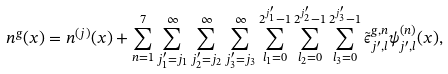<formula> <loc_0><loc_0><loc_500><loc_500>n ^ { g } ( { x } ) = n ^ { ( { j } ) } ( { x } ) + \sum _ { n = 1 } ^ { 7 } \sum _ { j ^ { \prime } _ { 1 } = j _ { 1 } } ^ { \infty } \sum _ { j ^ { \prime } _ { 2 } = j _ { 2 } } ^ { \infty } \sum _ { j ^ { \prime } _ { 3 } = j _ { 3 } } ^ { \infty } \sum _ { l _ { 1 } = 0 } ^ { 2 ^ { j ^ { \prime } _ { 1 } } - 1 } \sum _ { l _ { 2 } = 0 } ^ { 2 ^ { j ^ { \prime } _ { 2 } } - 1 } \sum _ { l _ { 3 } = 0 } ^ { 2 ^ { j ^ { \prime } _ { 3 } } - 1 } \tilde { \epsilon } ^ { g , n } _ { j ^ { \prime } , l } \psi _ { j ^ { \prime } , l } ^ { ( n ) } ( { x } ) ,</formula> 